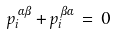Convert formula to latex. <formula><loc_0><loc_0><loc_500><loc_500>p ^ { \, \alpha \beta } _ { i } + p ^ { \, \beta \alpha } _ { i } \, = \, 0</formula> 